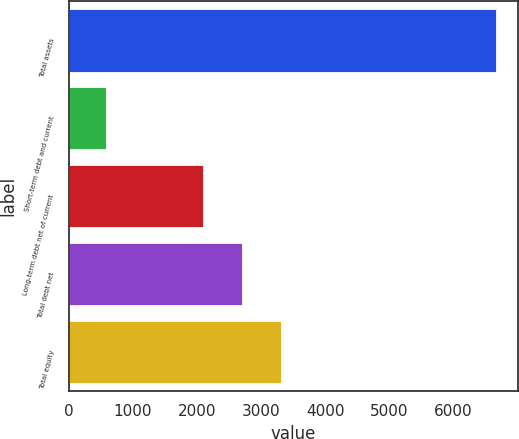<chart> <loc_0><loc_0><loc_500><loc_500><bar_chart><fcel>Total assets<fcel>Short-term debt and current<fcel>Long-term debt net of current<fcel>Total debt net<fcel>Total equity<nl><fcel>6664<fcel>585.4<fcel>2086.8<fcel>2694.66<fcel>3302.52<nl></chart> 